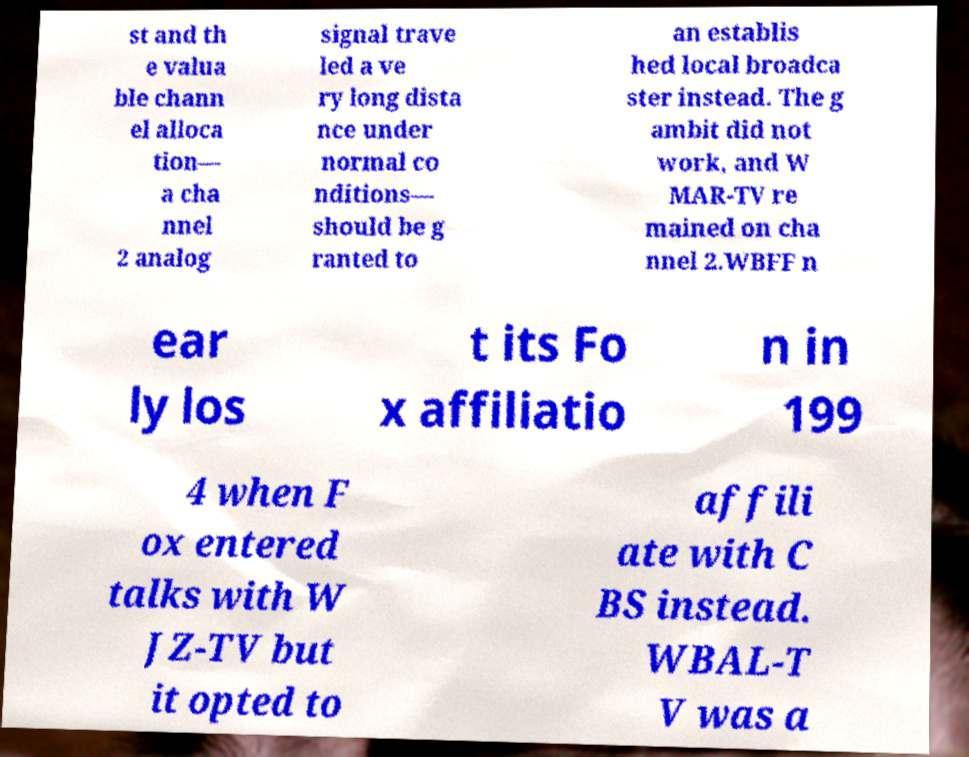I need the written content from this picture converted into text. Can you do that? st and th e valua ble chann el alloca tion— a cha nnel 2 analog signal trave led a ve ry long dista nce under normal co nditions— should be g ranted to an establis hed local broadca ster instead. The g ambit did not work, and W MAR-TV re mained on cha nnel 2.WBFF n ear ly los t its Fo x affiliatio n in 199 4 when F ox entered talks with W JZ-TV but it opted to affili ate with C BS instead. WBAL-T V was a 